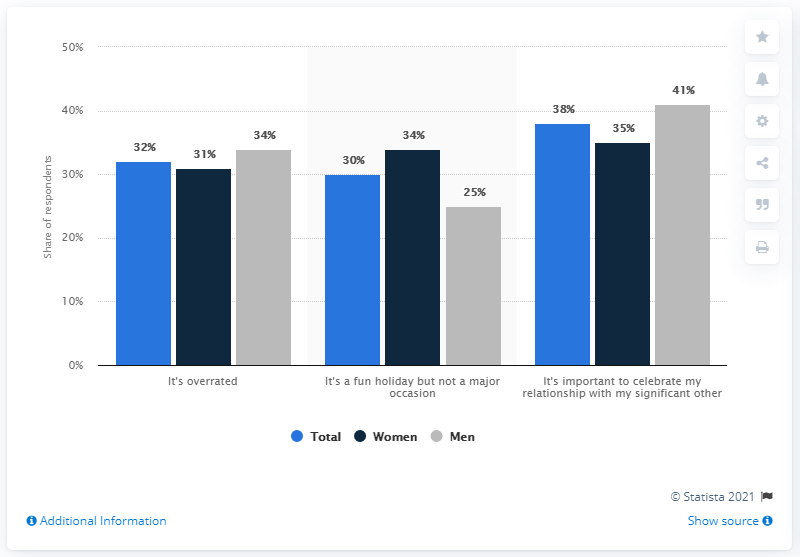Outline some significant characteristics in this image. The median value of all the bars is 34. A recent survey revealed that 32% of men believe that Valentine's Day is overrated. 